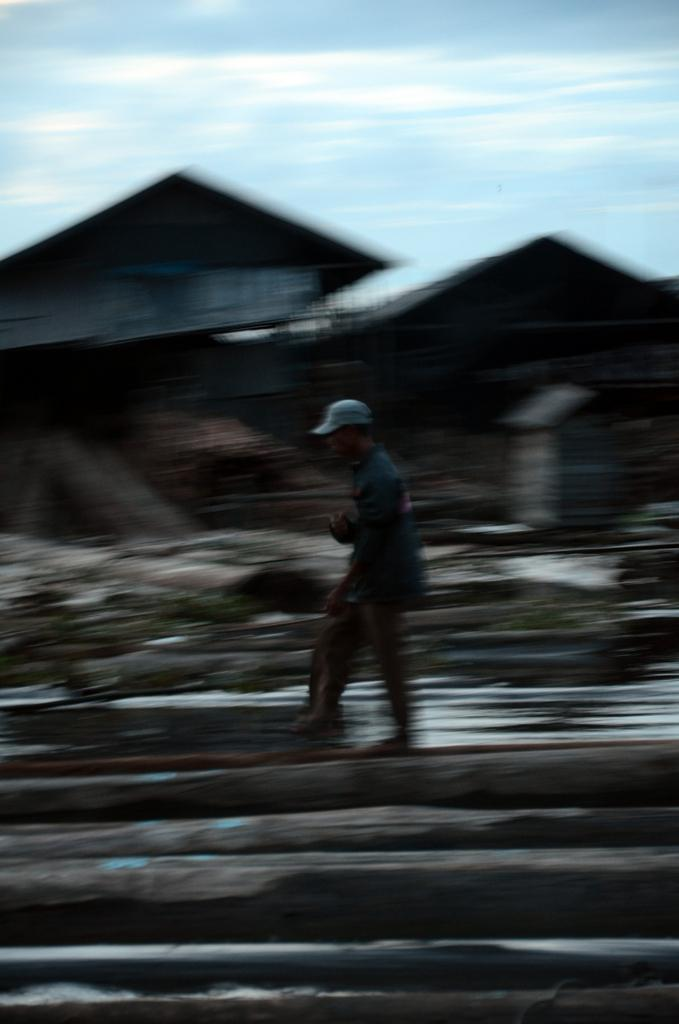What is the main action of the person in the image? There is a person walking in the image in the image. What is the person walking on? The person is walking on a wooden log. What can be seen in the background of the image? There are buildings and the sky visible in the background of the image. What is the purpose of the crib in the image? There is no crib present in the image. 